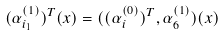Convert formula to latex. <formula><loc_0><loc_0><loc_500><loc_500>( \alpha _ { i _ { 1 } } ^ { ( 1 ) } ) ^ { T } ( x ) = ( ( \alpha _ { i } ^ { ( 0 ) } ) ^ { T } , \alpha _ { 6 } ^ { ( 1 ) } ) ( x )</formula> 